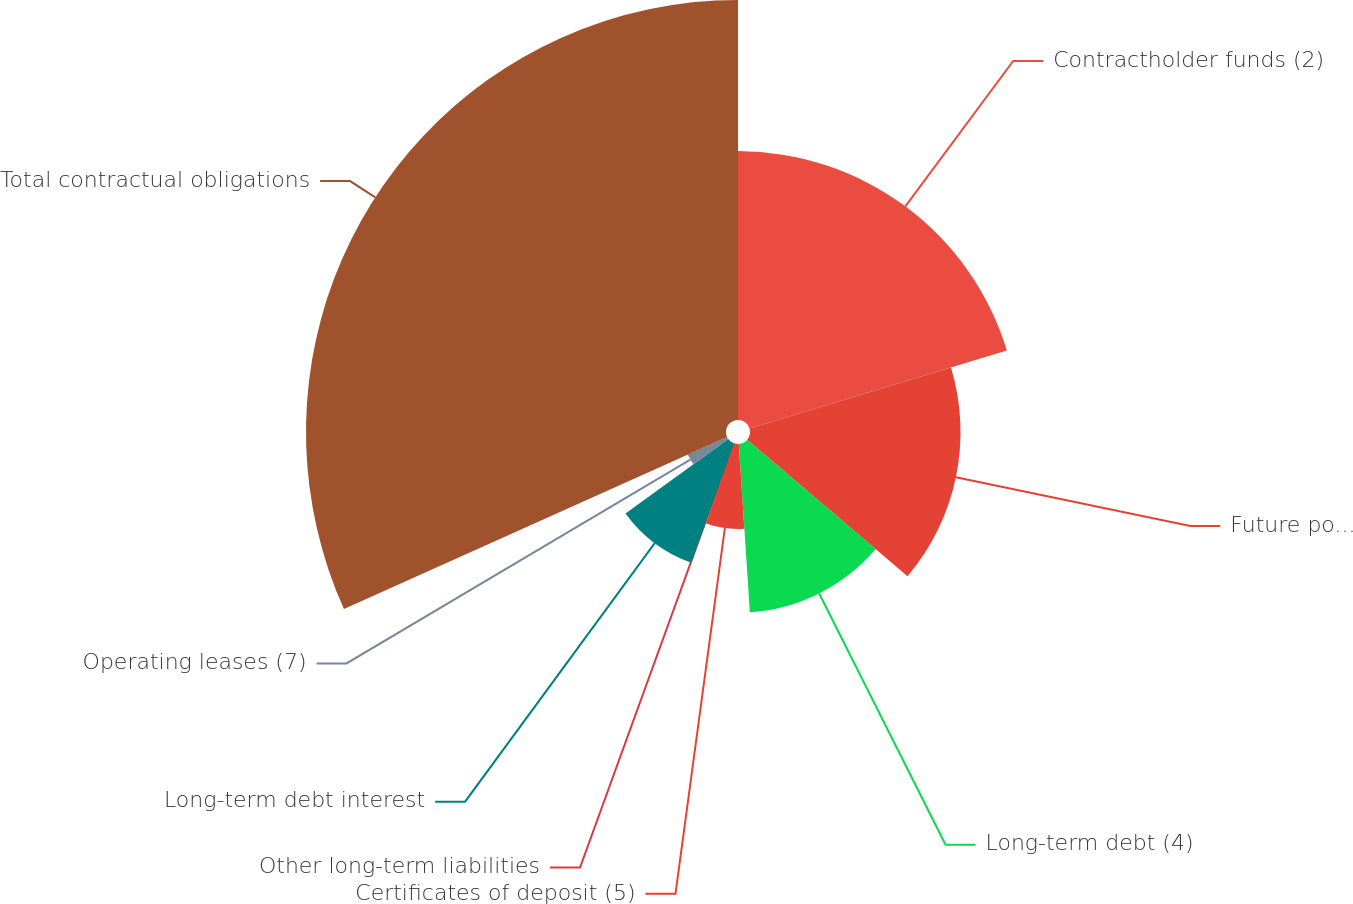Convert chart. <chart><loc_0><loc_0><loc_500><loc_500><pie_chart><fcel>Contractholder funds (2)<fcel>Future policy benefits and<fcel>Long-term debt (4)<fcel>Certificates of deposit (5)<fcel>Other long-term liabilities<fcel>Long-term debt interest<fcel>Operating leases (7)<fcel>Total contractual obligations<nl><fcel>20.31%<fcel>15.9%<fcel>12.74%<fcel>6.41%<fcel>0.08%<fcel>9.58%<fcel>3.25%<fcel>31.72%<nl></chart> 